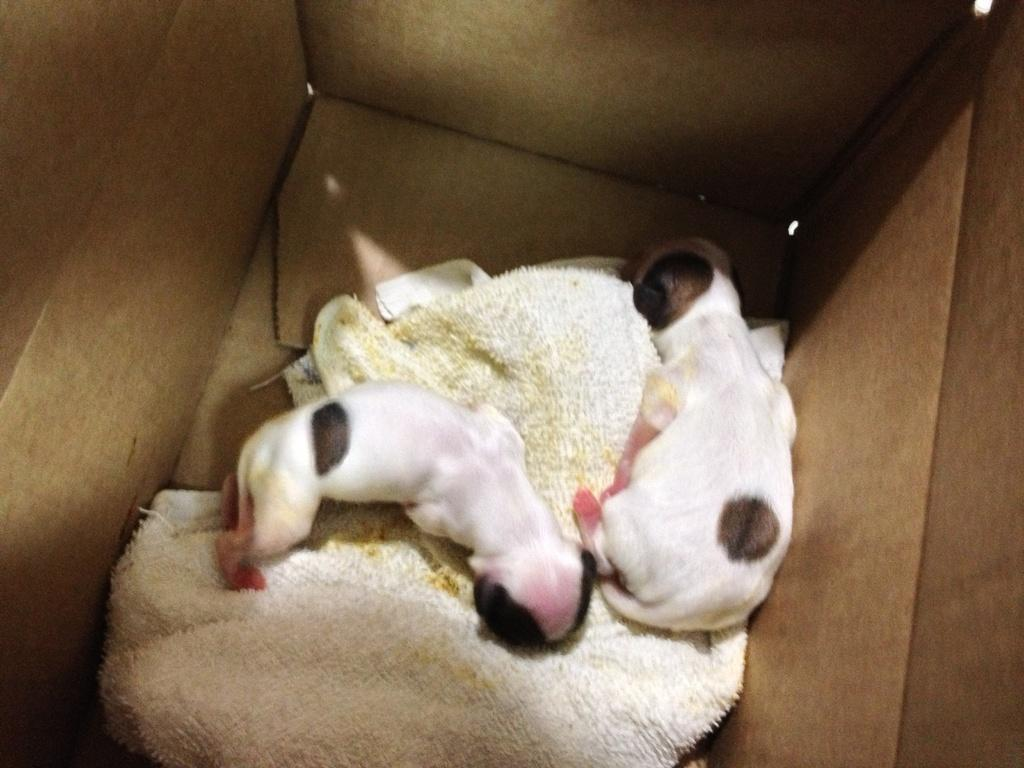How many puppies are present in the image? There are two puppies in the image. Where are the puppies located? The puppies are inside a box. What else can be seen in the image besides the puppies? There is a cloth in the image. What type of support is the cloth providing for the boys in the image? There are no boys present in the image, and therefore no support is being provided by the cloth. 